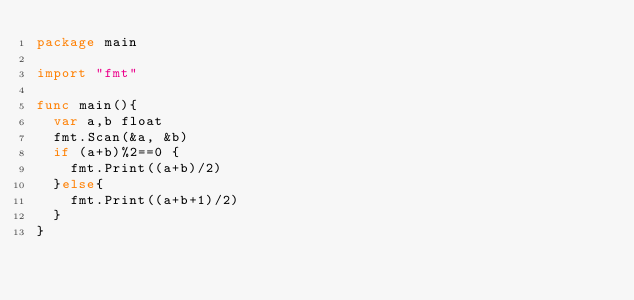<code> <loc_0><loc_0><loc_500><loc_500><_Go_>package main

import "fmt"

func main(){
  var a,b float
  fmt.Scan(&a, &b)
  if (a+b)%2==0 {
    fmt.Print((a+b)/2)
  }else{
    fmt.Print((a+b+1)/2)
  }
} </code> 